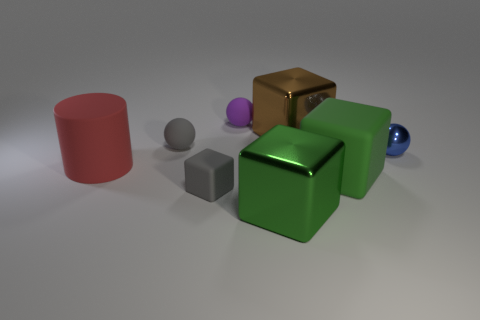How many objects are there in total, and can you describe their shapes? There are six objects in total. Starting from the left, there's a cylinder, a small sphere, a cube, another small sphere, a larger cube, and finally another sphere on the far right. The objects exhibit geometric simplicity, featuring common three-dimensional shapes like cubes, spheres, and a cylinder.  Is there a color theme or pattern to the arrangement of objects? The objects do not follow a strict color pattern but provide a contrast of colors. We see shades of red, purple, gray, green, gold, and blue. This variety gives the image a playful and varied palette, while the arrangement of objects seems random, with no apparent pattern in color distribution. 